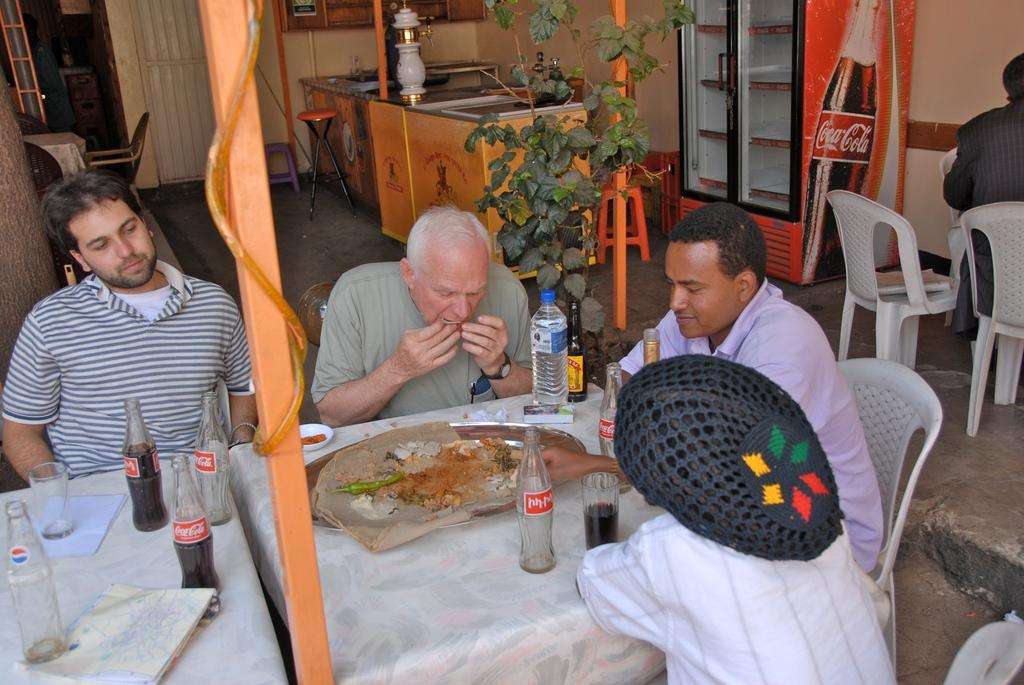What are the people in the image doing? The people in the image are sitting on chairs. What furniture is present in the image besides chairs? There are tables in the image. What can be seen on the tables? There is a glass and bottles on the tables. What can be seen in the background of the image? There is a plant and a stool in the background of the image. What type of jeans is the fly wearing in the image? There is no fly or jeans present in the image. 